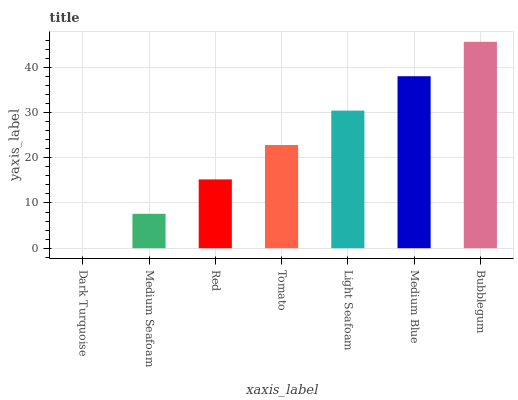Is Dark Turquoise the minimum?
Answer yes or no. Yes. Is Bubblegum the maximum?
Answer yes or no. Yes. Is Medium Seafoam the minimum?
Answer yes or no. No. Is Medium Seafoam the maximum?
Answer yes or no. No. Is Medium Seafoam greater than Dark Turquoise?
Answer yes or no. Yes. Is Dark Turquoise less than Medium Seafoam?
Answer yes or no. Yes. Is Dark Turquoise greater than Medium Seafoam?
Answer yes or no. No. Is Medium Seafoam less than Dark Turquoise?
Answer yes or no. No. Is Tomato the high median?
Answer yes or no. Yes. Is Tomato the low median?
Answer yes or no. Yes. Is Medium Blue the high median?
Answer yes or no. No. Is Dark Turquoise the low median?
Answer yes or no. No. 